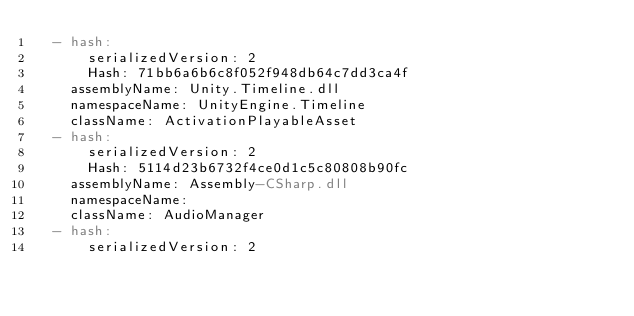Convert code to text. <code><loc_0><loc_0><loc_500><loc_500><_YAML_>  - hash:
      serializedVersion: 2
      Hash: 71bb6a6b6c8f052f948db64c7dd3ca4f
    assemblyName: Unity.Timeline.dll
    namespaceName: UnityEngine.Timeline
    className: ActivationPlayableAsset
  - hash:
      serializedVersion: 2
      Hash: 5114d23b6732f4ce0d1c5c80808b90fc
    assemblyName: Assembly-CSharp.dll
    namespaceName: 
    className: AudioManager
  - hash:
      serializedVersion: 2</code> 